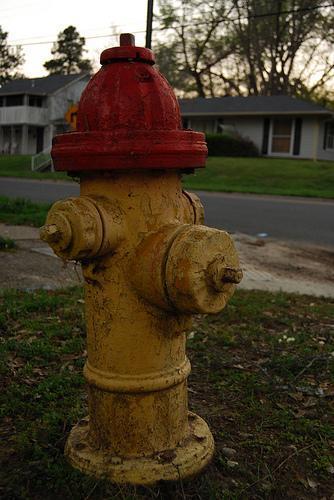How many fire hydrants are in the picture?
Give a very brief answer. 1. 